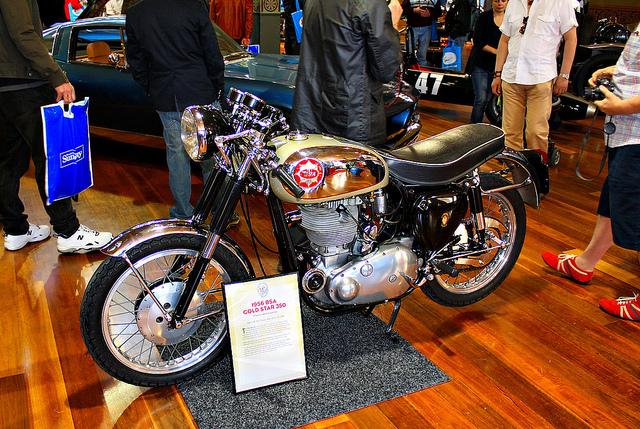Is this a motorcycle?
Be succinct. Yes. Is the motorcycle outside?
Keep it brief. No. What color are the shoes to the right of the bike?
Write a very short answer. Red. 